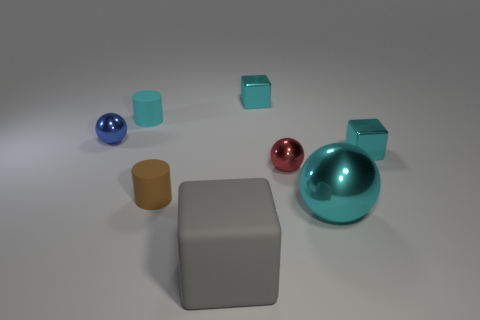Add 1 blue balls. How many objects exist? 9 Subtract all spheres. How many objects are left? 5 Add 5 tiny red metallic balls. How many tiny red metallic balls exist? 6 Subtract 0 yellow cylinders. How many objects are left? 8 Subtract all blue things. Subtract all big rubber cylinders. How many objects are left? 7 Add 5 large cyan balls. How many large cyan balls are left? 6 